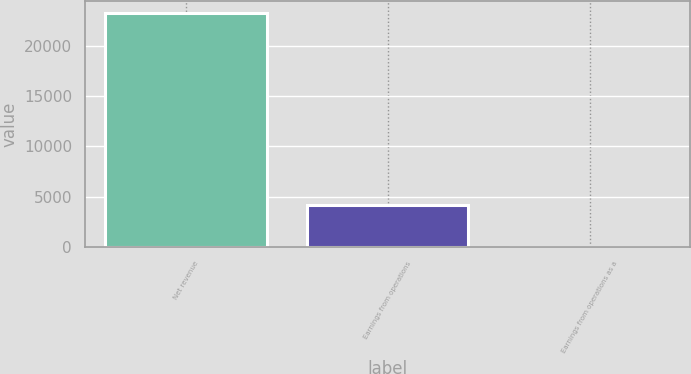Convert chart to OTSL. <chart><loc_0><loc_0><loc_500><loc_500><bar_chart><fcel>Net revenue<fcel>Earnings from operations<fcel>Earnings from operations as a<nl><fcel>23211<fcel>4229<fcel>18.2<nl></chart> 